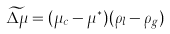Convert formula to latex. <formula><loc_0><loc_0><loc_500><loc_500>\widetilde { \Delta \mu } = ( \mu _ { c } - \mu ^ { * } ) ( \rho _ { l } - \rho _ { g } )</formula> 